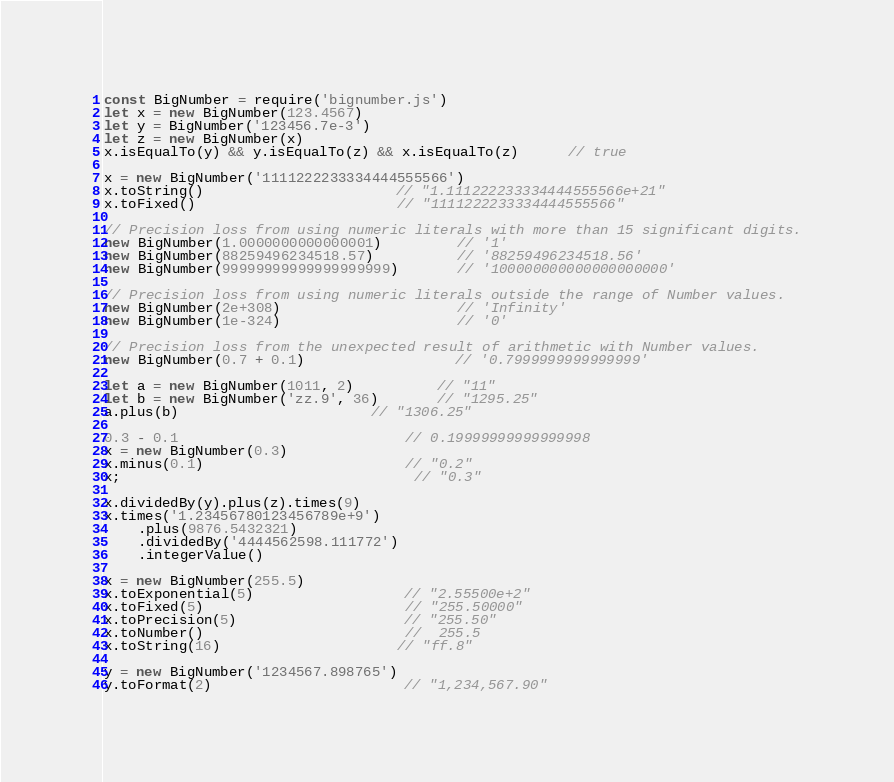Convert code to text. <code><loc_0><loc_0><loc_500><loc_500><_JavaScript_>const BigNumber = require('bignumber.js')
let x = new BigNumber(123.4567)
let y = BigNumber('123456.7e-3')
let z = new BigNumber(x)
x.isEqualTo(y) && y.isEqualTo(z) && x.isEqualTo(z)      // true

x = new BigNumber('1111222233334444555566')
x.toString()                       // "1.111222233334444555566e+21"
x.toFixed()                        // "1111222233334444555566"

// Precision loss from using numeric literals with more than 15 significant digits.
new BigNumber(1.0000000000000001)         // '1'
new BigNumber(88259496234518.57)          // '88259496234518.56'
new BigNumber(99999999999999999999)       // '100000000000000000000'

// Precision loss from using numeric literals outside the range of Number values.
new BigNumber(2e+308)                     // 'Infinity'
new BigNumber(1e-324)                     // '0'

// Precision loss from the unexpected result of arithmetic with Number values.
new BigNumber(0.7 + 0.1)                  // '0.7999999999999999'

let a = new BigNumber(1011, 2)          // "11"
let b = new BigNumber('zz.9', 36)       // "1295.25"
a.plus(b)                       // "1306.25"

0.3 - 0.1                           // 0.19999999999999998
x = new BigNumber(0.3)
x.minus(0.1)                        // "0.2"
x;                                   // "0.3"

x.dividedBy(y).plus(z).times(9)
x.times('1.23456780123456789e+9')
    .plus(9876.5432321)
    .dividedBy('4444562598.111772')
    .integerValue()

x = new BigNumber(255.5)
x.toExponential(5)                  // "2.55500e+2"
x.toFixed(5)                        // "255.50000"
x.toPrecision(5)                    // "255.50"
x.toNumber()                        //  255.5
x.toString(16)                     // "ff.8"

y = new BigNumber('1234567.898765')
y.toFormat(2)                       // "1,234,567.90"</code> 